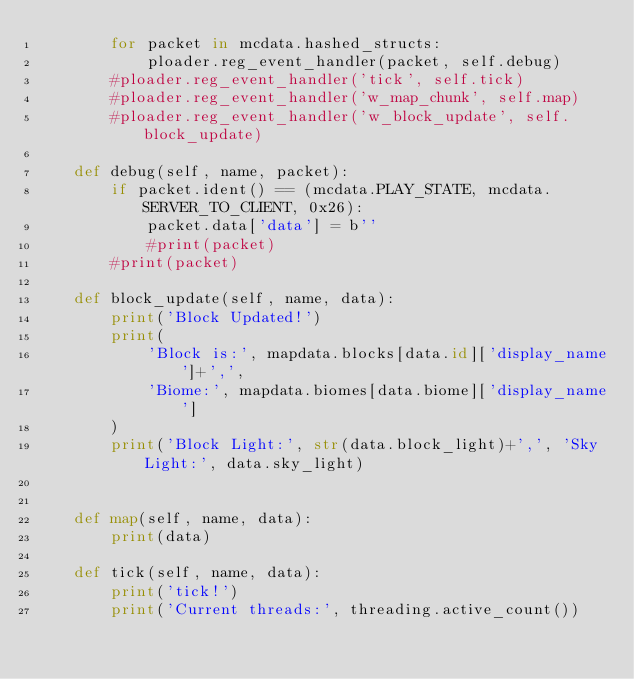<code> <loc_0><loc_0><loc_500><loc_500><_Python_>        for packet in mcdata.hashed_structs:
            ploader.reg_event_handler(packet, self.debug)
        #ploader.reg_event_handler('tick', self.tick)
        #ploader.reg_event_handler('w_map_chunk', self.map)
        #ploader.reg_event_handler('w_block_update', self.block_update)

    def debug(self, name, packet):
        if packet.ident() == (mcdata.PLAY_STATE, mcdata.SERVER_TO_CLIENT, 0x26):
            packet.data['data'] = b''
            #print(packet)
        #print(packet)

    def block_update(self, name, data):
        print('Block Updated!')
        print(
            'Block is:', mapdata.blocks[data.id]['display_name']+',',
            'Biome:', mapdata.biomes[data.biome]['display_name']
        )
        print('Block Light:', str(data.block_light)+',', 'Sky Light:', data.sky_light)


    def map(self, name, data):
        print(data)

    def tick(self, name, data):
        print('tick!')
        print('Current threads:', threading.active_count())</code> 